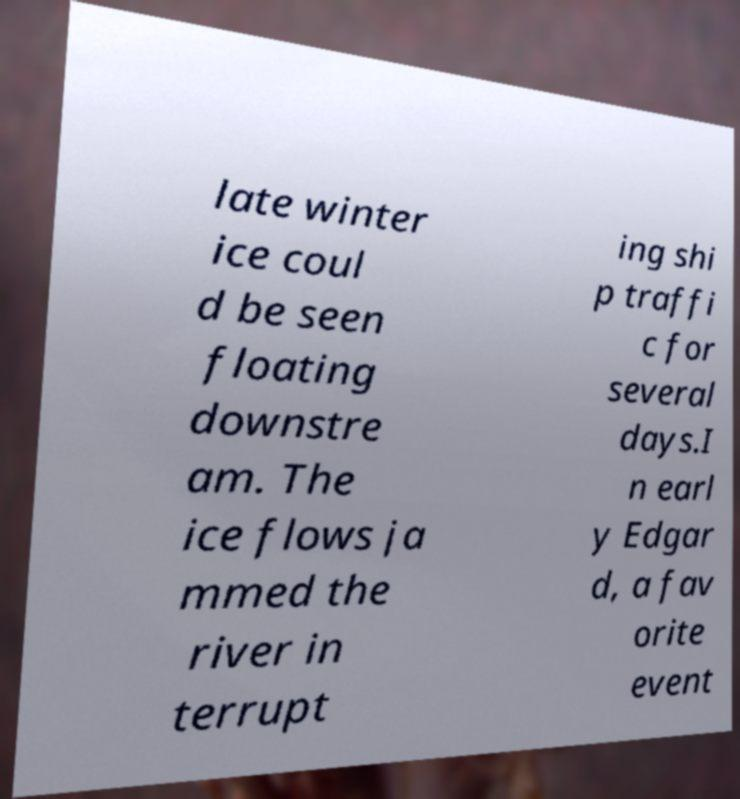I need the written content from this picture converted into text. Can you do that? late winter ice coul d be seen floating downstre am. The ice flows ja mmed the river in terrupt ing shi p traffi c for several days.I n earl y Edgar d, a fav orite event 